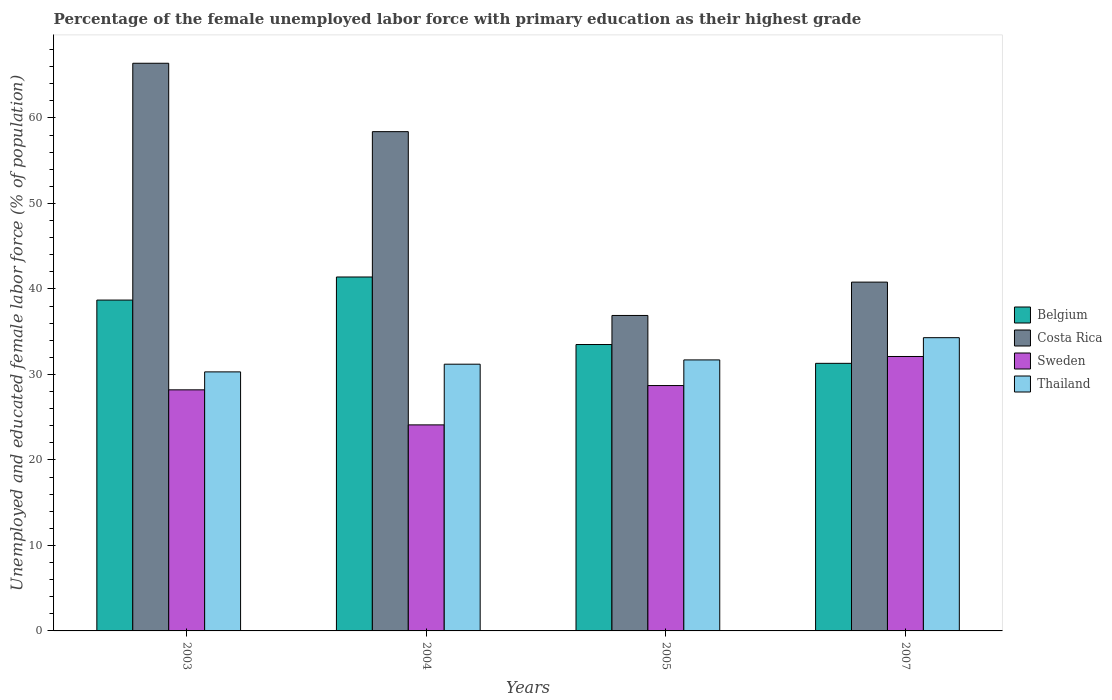Are the number of bars per tick equal to the number of legend labels?
Offer a terse response. Yes. How many bars are there on the 1st tick from the right?
Make the answer very short. 4. What is the label of the 3rd group of bars from the left?
Provide a short and direct response. 2005. In how many cases, is the number of bars for a given year not equal to the number of legend labels?
Your response must be concise. 0. What is the percentage of the unemployed female labor force with primary education in Sweden in 2005?
Your answer should be compact. 28.7. Across all years, what is the maximum percentage of the unemployed female labor force with primary education in Belgium?
Your answer should be compact. 41.4. Across all years, what is the minimum percentage of the unemployed female labor force with primary education in Belgium?
Give a very brief answer. 31.3. What is the total percentage of the unemployed female labor force with primary education in Costa Rica in the graph?
Keep it short and to the point. 202.5. What is the difference between the percentage of the unemployed female labor force with primary education in Thailand in 2003 and that in 2007?
Your answer should be very brief. -4. What is the difference between the percentage of the unemployed female labor force with primary education in Costa Rica in 2007 and the percentage of the unemployed female labor force with primary education in Belgium in 2005?
Your answer should be very brief. 7.3. What is the average percentage of the unemployed female labor force with primary education in Sweden per year?
Your answer should be compact. 28.28. In the year 2003, what is the difference between the percentage of the unemployed female labor force with primary education in Costa Rica and percentage of the unemployed female labor force with primary education in Sweden?
Your answer should be compact. 38.2. What is the ratio of the percentage of the unemployed female labor force with primary education in Sweden in 2003 to that in 2005?
Offer a very short reply. 0.98. What is the difference between the highest and the second highest percentage of the unemployed female labor force with primary education in Thailand?
Ensure brevity in your answer.  2.6. What is the difference between the highest and the lowest percentage of the unemployed female labor force with primary education in Costa Rica?
Your response must be concise. 29.5. In how many years, is the percentage of the unemployed female labor force with primary education in Belgium greater than the average percentage of the unemployed female labor force with primary education in Belgium taken over all years?
Give a very brief answer. 2. What does the 3rd bar from the left in 2007 represents?
Provide a succinct answer. Sweden. Does the graph contain any zero values?
Ensure brevity in your answer.  No. Does the graph contain grids?
Make the answer very short. No. How are the legend labels stacked?
Offer a very short reply. Vertical. What is the title of the graph?
Your response must be concise. Percentage of the female unemployed labor force with primary education as their highest grade. What is the label or title of the X-axis?
Your answer should be very brief. Years. What is the label or title of the Y-axis?
Ensure brevity in your answer.  Unemployed and educated female labor force (% of population). What is the Unemployed and educated female labor force (% of population) in Belgium in 2003?
Your response must be concise. 38.7. What is the Unemployed and educated female labor force (% of population) of Costa Rica in 2003?
Provide a succinct answer. 66.4. What is the Unemployed and educated female labor force (% of population) in Sweden in 2003?
Keep it short and to the point. 28.2. What is the Unemployed and educated female labor force (% of population) in Thailand in 2003?
Provide a short and direct response. 30.3. What is the Unemployed and educated female labor force (% of population) in Belgium in 2004?
Offer a terse response. 41.4. What is the Unemployed and educated female labor force (% of population) of Costa Rica in 2004?
Keep it short and to the point. 58.4. What is the Unemployed and educated female labor force (% of population) in Sweden in 2004?
Ensure brevity in your answer.  24.1. What is the Unemployed and educated female labor force (% of population) of Thailand in 2004?
Your answer should be compact. 31.2. What is the Unemployed and educated female labor force (% of population) in Belgium in 2005?
Offer a terse response. 33.5. What is the Unemployed and educated female labor force (% of population) of Costa Rica in 2005?
Provide a short and direct response. 36.9. What is the Unemployed and educated female labor force (% of population) of Sweden in 2005?
Your answer should be compact. 28.7. What is the Unemployed and educated female labor force (% of population) in Thailand in 2005?
Ensure brevity in your answer.  31.7. What is the Unemployed and educated female labor force (% of population) in Belgium in 2007?
Provide a short and direct response. 31.3. What is the Unemployed and educated female labor force (% of population) in Costa Rica in 2007?
Keep it short and to the point. 40.8. What is the Unemployed and educated female labor force (% of population) in Sweden in 2007?
Provide a succinct answer. 32.1. What is the Unemployed and educated female labor force (% of population) in Thailand in 2007?
Provide a succinct answer. 34.3. Across all years, what is the maximum Unemployed and educated female labor force (% of population) in Belgium?
Offer a terse response. 41.4. Across all years, what is the maximum Unemployed and educated female labor force (% of population) in Costa Rica?
Provide a short and direct response. 66.4. Across all years, what is the maximum Unemployed and educated female labor force (% of population) of Sweden?
Ensure brevity in your answer.  32.1. Across all years, what is the maximum Unemployed and educated female labor force (% of population) in Thailand?
Your answer should be compact. 34.3. Across all years, what is the minimum Unemployed and educated female labor force (% of population) in Belgium?
Your answer should be compact. 31.3. Across all years, what is the minimum Unemployed and educated female labor force (% of population) in Costa Rica?
Offer a terse response. 36.9. Across all years, what is the minimum Unemployed and educated female labor force (% of population) of Sweden?
Your answer should be compact. 24.1. Across all years, what is the minimum Unemployed and educated female labor force (% of population) of Thailand?
Your response must be concise. 30.3. What is the total Unemployed and educated female labor force (% of population) in Belgium in the graph?
Your answer should be very brief. 144.9. What is the total Unemployed and educated female labor force (% of population) in Costa Rica in the graph?
Provide a short and direct response. 202.5. What is the total Unemployed and educated female labor force (% of population) in Sweden in the graph?
Your answer should be very brief. 113.1. What is the total Unemployed and educated female labor force (% of population) in Thailand in the graph?
Offer a very short reply. 127.5. What is the difference between the Unemployed and educated female labor force (% of population) of Belgium in 2003 and that in 2004?
Provide a succinct answer. -2.7. What is the difference between the Unemployed and educated female labor force (% of population) in Costa Rica in 2003 and that in 2004?
Your answer should be very brief. 8. What is the difference between the Unemployed and educated female labor force (% of population) in Sweden in 2003 and that in 2004?
Ensure brevity in your answer.  4.1. What is the difference between the Unemployed and educated female labor force (% of population) of Belgium in 2003 and that in 2005?
Provide a succinct answer. 5.2. What is the difference between the Unemployed and educated female labor force (% of population) in Costa Rica in 2003 and that in 2005?
Offer a very short reply. 29.5. What is the difference between the Unemployed and educated female labor force (% of population) of Thailand in 2003 and that in 2005?
Keep it short and to the point. -1.4. What is the difference between the Unemployed and educated female labor force (% of population) in Costa Rica in 2003 and that in 2007?
Ensure brevity in your answer.  25.6. What is the difference between the Unemployed and educated female labor force (% of population) in Belgium in 2004 and that in 2005?
Keep it short and to the point. 7.9. What is the difference between the Unemployed and educated female labor force (% of population) in Costa Rica in 2004 and that in 2005?
Give a very brief answer. 21.5. What is the difference between the Unemployed and educated female labor force (% of population) of Belgium in 2005 and that in 2007?
Offer a terse response. 2.2. What is the difference between the Unemployed and educated female labor force (% of population) of Costa Rica in 2005 and that in 2007?
Provide a short and direct response. -3.9. What is the difference between the Unemployed and educated female labor force (% of population) in Sweden in 2005 and that in 2007?
Your response must be concise. -3.4. What is the difference between the Unemployed and educated female labor force (% of population) of Thailand in 2005 and that in 2007?
Your answer should be very brief. -2.6. What is the difference between the Unemployed and educated female labor force (% of population) of Belgium in 2003 and the Unemployed and educated female labor force (% of population) of Costa Rica in 2004?
Keep it short and to the point. -19.7. What is the difference between the Unemployed and educated female labor force (% of population) in Belgium in 2003 and the Unemployed and educated female labor force (% of population) in Sweden in 2004?
Your answer should be very brief. 14.6. What is the difference between the Unemployed and educated female labor force (% of population) of Costa Rica in 2003 and the Unemployed and educated female labor force (% of population) of Sweden in 2004?
Make the answer very short. 42.3. What is the difference between the Unemployed and educated female labor force (% of population) of Costa Rica in 2003 and the Unemployed and educated female labor force (% of population) of Thailand in 2004?
Offer a very short reply. 35.2. What is the difference between the Unemployed and educated female labor force (% of population) in Sweden in 2003 and the Unemployed and educated female labor force (% of population) in Thailand in 2004?
Your response must be concise. -3. What is the difference between the Unemployed and educated female labor force (% of population) of Belgium in 2003 and the Unemployed and educated female labor force (% of population) of Sweden in 2005?
Make the answer very short. 10. What is the difference between the Unemployed and educated female labor force (% of population) in Costa Rica in 2003 and the Unemployed and educated female labor force (% of population) in Sweden in 2005?
Offer a very short reply. 37.7. What is the difference between the Unemployed and educated female labor force (% of population) of Costa Rica in 2003 and the Unemployed and educated female labor force (% of population) of Thailand in 2005?
Your answer should be very brief. 34.7. What is the difference between the Unemployed and educated female labor force (% of population) of Sweden in 2003 and the Unemployed and educated female labor force (% of population) of Thailand in 2005?
Make the answer very short. -3.5. What is the difference between the Unemployed and educated female labor force (% of population) in Belgium in 2003 and the Unemployed and educated female labor force (% of population) in Sweden in 2007?
Your answer should be compact. 6.6. What is the difference between the Unemployed and educated female labor force (% of population) of Belgium in 2003 and the Unemployed and educated female labor force (% of population) of Thailand in 2007?
Give a very brief answer. 4.4. What is the difference between the Unemployed and educated female labor force (% of population) in Costa Rica in 2003 and the Unemployed and educated female labor force (% of population) in Sweden in 2007?
Your answer should be compact. 34.3. What is the difference between the Unemployed and educated female labor force (% of population) in Costa Rica in 2003 and the Unemployed and educated female labor force (% of population) in Thailand in 2007?
Keep it short and to the point. 32.1. What is the difference between the Unemployed and educated female labor force (% of population) of Belgium in 2004 and the Unemployed and educated female labor force (% of population) of Costa Rica in 2005?
Your answer should be compact. 4.5. What is the difference between the Unemployed and educated female labor force (% of population) in Costa Rica in 2004 and the Unemployed and educated female labor force (% of population) in Sweden in 2005?
Your response must be concise. 29.7. What is the difference between the Unemployed and educated female labor force (% of population) in Costa Rica in 2004 and the Unemployed and educated female labor force (% of population) in Thailand in 2005?
Provide a succinct answer. 26.7. What is the difference between the Unemployed and educated female labor force (% of population) in Sweden in 2004 and the Unemployed and educated female labor force (% of population) in Thailand in 2005?
Keep it short and to the point. -7.6. What is the difference between the Unemployed and educated female labor force (% of population) in Belgium in 2004 and the Unemployed and educated female labor force (% of population) in Thailand in 2007?
Offer a very short reply. 7.1. What is the difference between the Unemployed and educated female labor force (% of population) of Costa Rica in 2004 and the Unemployed and educated female labor force (% of population) of Sweden in 2007?
Ensure brevity in your answer.  26.3. What is the difference between the Unemployed and educated female labor force (% of population) in Costa Rica in 2004 and the Unemployed and educated female labor force (% of population) in Thailand in 2007?
Offer a terse response. 24.1. What is the difference between the Unemployed and educated female labor force (% of population) of Sweden in 2004 and the Unemployed and educated female labor force (% of population) of Thailand in 2007?
Keep it short and to the point. -10.2. What is the difference between the Unemployed and educated female labor force (% of population) in Belgium in 2005 and the Unemployed and educated female labor force (% of population) in Sweden in 2007?
Offer a terse response. 1.4. What is the difference between the Unemployed and educated female labor force (% of population) of Belgium in 2005 and the Unemployed and educated female labor force (% of population) of Thailand in 2007?
Your answer should be compact. -0.8. What is the difference between the Unemployed and educated female labor force (% of population) of Sweden in 2005 and the Unemployed and educated female labor force (% of population) of Thailand in 2007?
Offer a terse response. -5.6. What is the average Unemployed and educated female labor force (% of population) of Belgium per year?
Offer a terse response. 36.23. What is the average Unemployed and educated female labor force (% of population) of Costa Rica per year?
Offer a terse response. 50.62. What is the average Unemployed and educated female labor force (% of population) in Sweden per year?
Offer a terse response. 28.27. What is the average Unemployed and educated female labor force (% of population) in Thailand per year?
Provide a succinct answer. 31.88. In the year 2003, what is the difference between the Unemployed and educated female labor force (% of population) in Belgium and Unemployed and educated female labor force (% of population) in Costa Rica?
Your answer should be very brief. -27.7. In the year 2003, what is the difference between the Unemployed and educated female labor force (% of population) of Belgium and Unemployed and educated female labor force (% of population) of Thailand?
Offer a terse response. 8.4. In the year 2003, what is the difference between the Unemployed and educated female labor force (% of population) in Costa Rica and Unemployed and educated female labor force (% of population) in Sweden?
Your answer should be compact. 38.2. In the year 2003, what is the difference between the Unemployed and educated female labor force (% of population) in Costa Rica and Unemployed and educated female labor force (% of population) in Thailand?
Provide a short and direct response. 36.1. In the year 2004, what is the difference between the Unemployed and educated female labor force (% of population) of Belgium and Unemployed and educated female labor force (% of population) of Costa Rica?
Offer a terse response. -17. In the year 2004, what is the difference between the Unemployed and educated female labor force (% of population) of Belgium and Unemployed and educated female labor force (% of population) of Sweden?
Make the answer very short. 17.3. In the year 2004, what is the difference between the Unemployed and educated female labor force (% of population) in Costa Rica and Unemployed and educated female labor force (% of population) in Sweden?
Your response must be concise. 34.3. In the year 2004, what is the difference between the Unemployed and educated female labor force (% of population) in Costa Rica and Unemployed and educated female labor force (% of population) in Thailand?
Provide a succinct answer. 27.2. In the year 2004, what is the difference between the Unemployed and educated female labor force (% of population) in Sweden and Unemployed and educated female labor force (% of population) in Thailand?
Keep it short and to the point. -7.1. In the year 2005, what is the difference between the Unemployed and educated female labor force (% of population) of Belgium and Unemployed and educated female labor force (% of population) of Costa Rica?
Your answer should be compact. -3.4. In the year 2005, what is the difference between the Unemployed and educated female labor force (% of population) of Belgium and Unemployed and educated female labor force (% of population) of Thailand?
Ensure brevity in your answer.  1.8. In the year 2005, what is the difference between the Unemployed and educated female labor force (% of population) of Costa Rica and Unemployed and educated female labor force (% of population) of Sweden?
Provide a succinct answer. 8.2. In the year 2007, what is the difference between the Unemployed and educated female labor force (% of population) in Belgium and Unemployed and educated female labor force (% of population) in Costa Rica?
Offer a terse response. -9.5. In the year 2007, what is the difference between the Unemployed and educated female labor force (% of population) of Costa Rica and Unemployed and educated female labor force (% of population) of Thailand?
Offer a terse response. 6.5. What is the ratio of the Unemployed and educated female labor force (% of population) of Belgium in 2003 to that in 2004?
Your answer should be compact. 0.93. What is the ratio of the Unemployed and educated female labor force (% of population) in Costa Rica in 2003 to that in 2004?
Your answer should be compact. 1.14. What is the ratio of the Unemployed and educated female labor force (% of population) of Sweden in 2003 to that in 2004?
Your answer should be very brief. 1.17. What is the ratio of the Unemployed and educated female labor force (% of population) in Thailand in 2003 to that in 2004?
Keep it short and to the point. 0.97. What is the ratio of the Unemployed and educated female labor force (% of population) of Belgium in 2003 to that in 2005?
Provide a succinct answer. 1.16. What is the ratio of the Unemployed and educated female labor force (% of population) of Costa Rica in 2003 to that in 2005?
Ensure brevity in your answer.  1.8. What is the ratio of the Unemployed and educated female labor force (% of population) of Sweden in 2003 to that in 2005?
Give a very brief answer. 0.98. What is the ratio of the Unemployed and educated female labor force (% of population) of Thailand in 2003 to that in 2005?
Keep it short and to the point. 0.96. What is the ratio of the Unemployed and educated female labor force (% of population) of Belgium in 2003 to that in 2007?
Your answer should be compact. 1.24. What is the ratio of the Unemployed and educated female labor force (% of population) in Costa Rica in 2003 to that in 2007?
Offer a very short reply. 1.63. What is the ratio of the Unemployed and educated female labor force (% of population) in Sweden in 2003 to that in 2007?
Ensure brevity in your answer.  0.88. What is the ratio of the Unemployed and educated female labor force (% of population) of Thailand in 2003 to that in 2007?
Offer a terse response. 0.88. What is the ratio of the Unemployed and educated female labor force (% of population) in Belgium in 2004 to that in 2005?
Provide a short and direct response. 1.24. What is the ratio of the Unemployed and educated female labor force (% of population) of Costa Rica in 2004 to that in 2005?
Provide a succinct answer. 1.58. What is the ratio of the Unemployed and educated female labor force (% of population) in Sweden in 2004 to that in 2005?
Provide a short and direct response. 0.84. What is the ratio of the Unemployed and educated female labor force (% of population) of Thailand in 2004 to that in 2005?
Your response must be concise. 0.98. What is the ratio of the Unemployed and educated female labor force (% of population) of Belgium in 2004 to that in 2007?
Offer a terse response. 1.32. What is the ratio of the Unemployed and educated female labor force (% of population) of Costa Rica in 2004 to that in 2007?
Give a very brief answer. 1.43. What is the ratio of the Unemployed and educated female labor force (% of population) in Sweden in 2004 to that in 2007?
Give a very brief answer. 0.75. What is the ratio of the Unemployed and educated female labor force (% of population) of Thailand in 2004 to that in 2007?
Your answer should be compact. 0.91. What is the ratio of the Unemployed and educated female labor force (% of population) in Belgium in 2005 to that in 2007?
Your answer should be compact. 1.07. What is the ratio of the Unemployed and educated female labor force (% of population) in Costa Rica in 2005 to that in 2007?
Provide a short and direct response. 0.9. What is the ratio of the Unemployed and educated female labor force (% of population) of Sweden in 2005 to that in 2007?
Your answer should be compact. 0.89. What is the ratio of the Unemployed and educated female labor force (% of population) in Thailand in 2005 to that in 2007?
Offer a very short reply. 0.92. What is the difference between the highest and the second highest Unemployed and educated female labor force (% of population) of Belgium?
Your answer should be very brief. 2.7. What is the difference between the highest and the second highest Unemployed and educated female labor force (% of population) in Costa Rica?
Provide a succinct answer. 8. What is the difference between the highest and the lowest Unemployed and educated female labor force (% of population) in Costa Rica?
Your answer should be compact. 29.5. What is the difference between the highest and the lowest Unemployed and educated female labor force (% of population) in Thailand?
Keep it short and to the point. 4. 